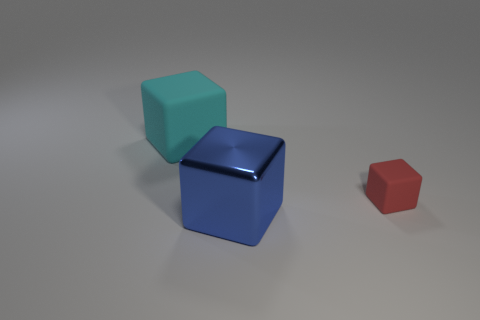What number of large blue metallic things are the same shape as the small red thing?
Give a very brief answer. 1. There is a rubber thing that is to the left of the blue block; is it the same color as the matte block that is right of the blue metallic cube?
Keep it short and to the point. No. There is a cube that is the same size as the blue object; what is its material?
Ensure brevity in your answer.  Rubber. Are there any blue shiny things of the same size as the red rubber object?
Make the answer very short. No. Are there fewer big blocks that are to the right of the big cyan matte object than small brown objects?
Ensure brevity in your answer.  No. Is the number of metal blocks left of the big cyan matte cube less than the number of tiny red rubber cubes to the left of the large blue metallic object?
Make the answer very short. No. What number of cubes are either yellow shiny things or blue things?
Ensure brevity in your answer.  1. Are the large thing behind the tiny red cube and the large object in front of the tiny red matte object made of the same material?
Provide a succinct answer. No. The cyan thing that is the same size as the blue shiny cube is what shape?
Offer a terse response. Cube. What number of other objects are there of the same color as the small rubber cube?
Your response must be concise. 0. 